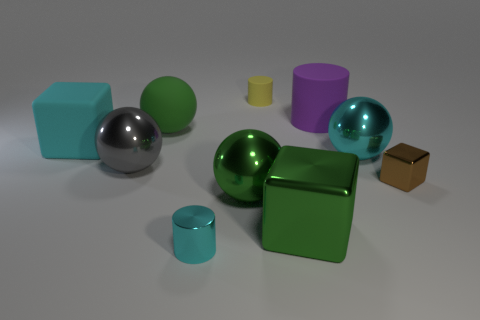Subtract all green balls. How many balls are left? 2 Subtract all shiny cubes. How many cubes are left? 1 Subtract 1 gray balls. How many objects are left? 9 Subtract all spheres. How many objects are left? 6 Subtract 2 cylinders. How many cylinders are left? 1 Subtract all cyan blocks. Subtract all brown balls. How many blocks are left? 2 Subtract all brown cubes. How many cyan cylinders are left? 1 Subtract all metal spheres. Subtract all small shiny cylinders. How many objects are left? 6 Add 4 small cylinders. How many small cylinders are left? 6 Add 1 green rubber spheres. How many green rubber spheres exist? 2 